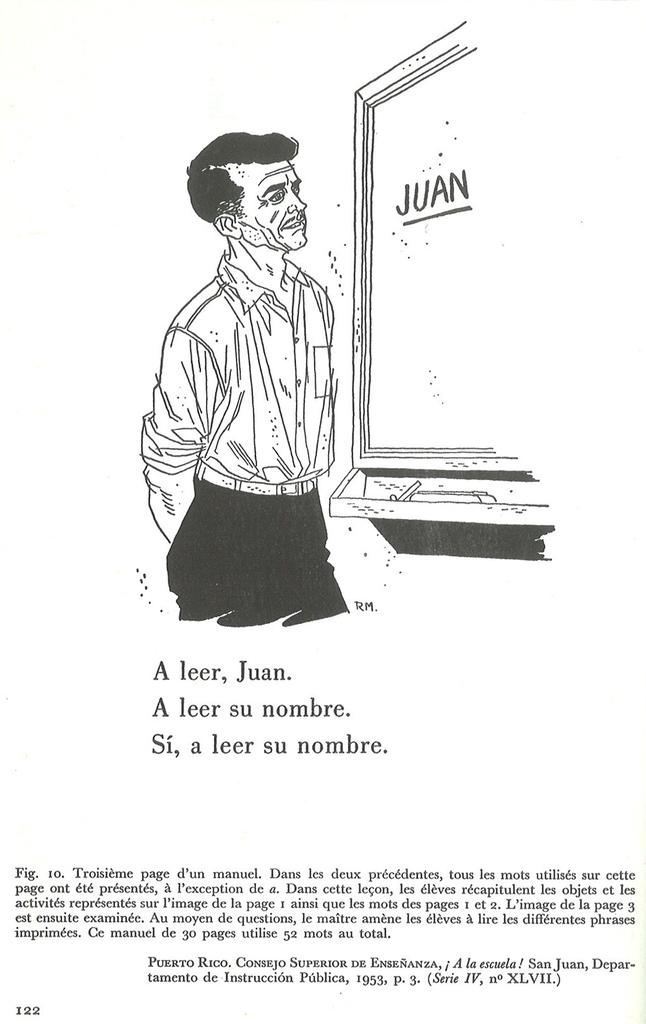What is the main subject of the poster in the image? The main subject of the poster in the image is a cartoon person. Where is the cartoon person located in relation to other objects on the poster? The cartoon person is standing near a mirror. What is written at the bottom of the poster? There is text written at the bottom of the poster. What type of van can be seen parked near the camp in the image? There is no van or camp present in the image; it features a poster with a cartoon person standing near a mirror. 